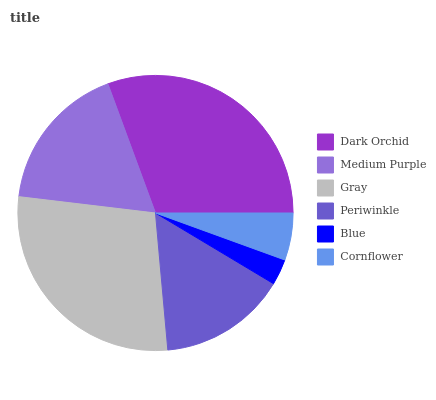Is Blue the minimum?
Answer yes or no. Yes. Is Dark Orchid the maximum?
Answer yes or no. Yes. Is Medium Purple the minimum?
Answer yes or no. No. Is Medium Purple the maximum?
Answer yes or no. No. Is Dark Orchid greater than Medium Purple?
Answer yes or no. Yes. Is Medium Purple less than Dark Orchid?
Answer yes or no. Yes. Is Medium Purple greater than Dark Orchid?
Answer yes or no. No. Is Dark Orchid less than Medium Purple?
Answer yes or no. No. Is Medium Purple the high median?
Answer yes or no. Yes. Is Periwinkle the low median?
Answer yes or no. Yes. Is Gray the high median?
Answer yes or no. No. Is Blue the low median?
Answer yes or no. No. 